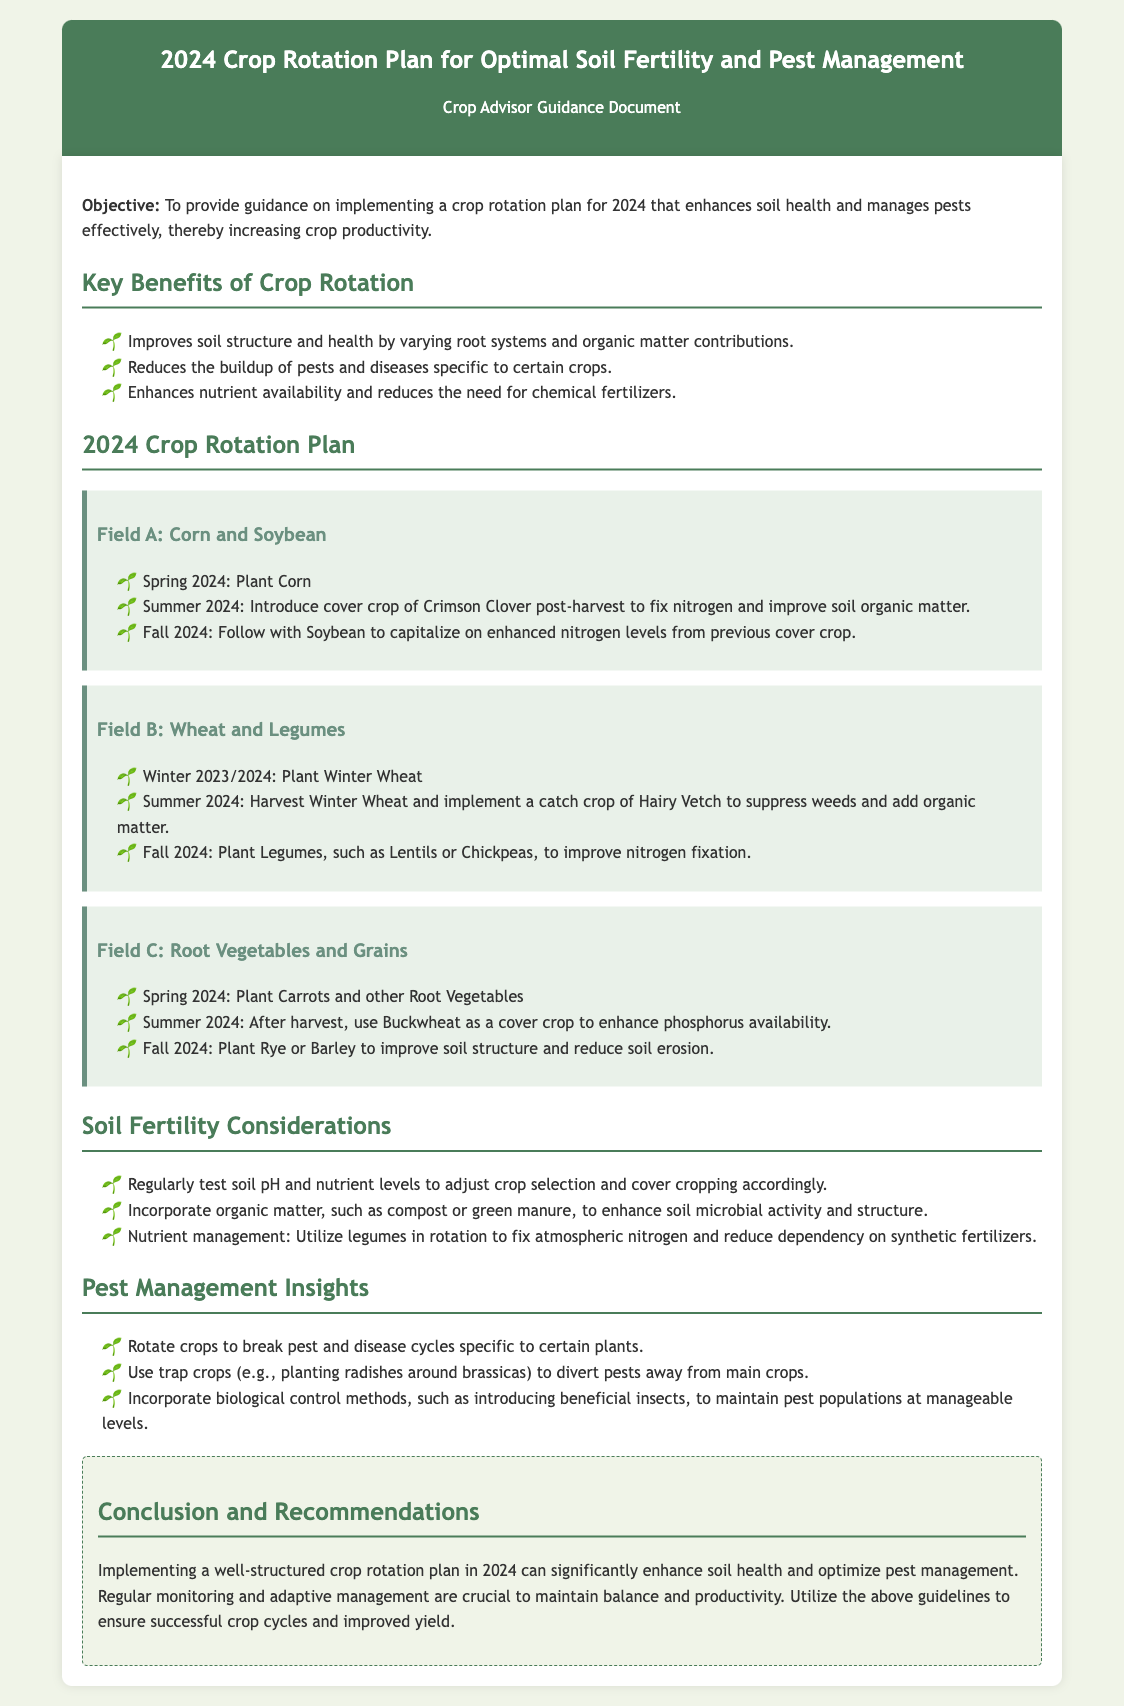What is the objective of the document? The objective is to provide guidance on implementing a crop rotation plan for 2024 that enhances soil health and manages pests effectively, thereby increasing crop productivity.
Answer: To provide guidance on implementing a crop rotation plan for 2024 that enhances soil health and manages pests effectively, thereby increasing crop productivity What cover crop is introduced post-harvest in Field A? The cover crop introduced post-harvest in Field A is Crimson Clover, which fixes nitrogen and improves soil organic matter.
Answer: Crimson Clover Which crops are planted in Field B after harvesting Winter Wheat? The crops planted in Field B after harvesting Winter Wheat are Legumes, such as Lentils or Chickpeas, to improve nitrogen fixation.
Answer: Legumes, such as Lentils or Chickpeas What should be incorporated regularly to enhance soil fertility? Regular incorporation of organic matter, such as compost or green manure, is recommended to enhance soil microbial activity and structure.
Answer: Organic matter, such as compost or green manure What is a recommended biological control method for pest management? Introducing beneficial insects is a recommended biological control method to maintain pest populations at manageable levels.
Answer: Introducing beneficial insects How many fields are detailed in the crop rotation plan? The document details three fields: Field A, Field B, and Field C.
Answer: Three fields What is the suggested cover crop to enhance phosphorus availability in Field C? Buckwheat is suggested as a cover crop to enhance phosphorus availability in Field C.
Answer: Buckwheat What is the main benefit of crop rotation mentioned in the document? A main benefit of crop rotation mentioned is that it reduces the buildup of pests and diseases specific to certain crops.
Answer: Reduces the buildup of pests and diseases specific to certain crops 